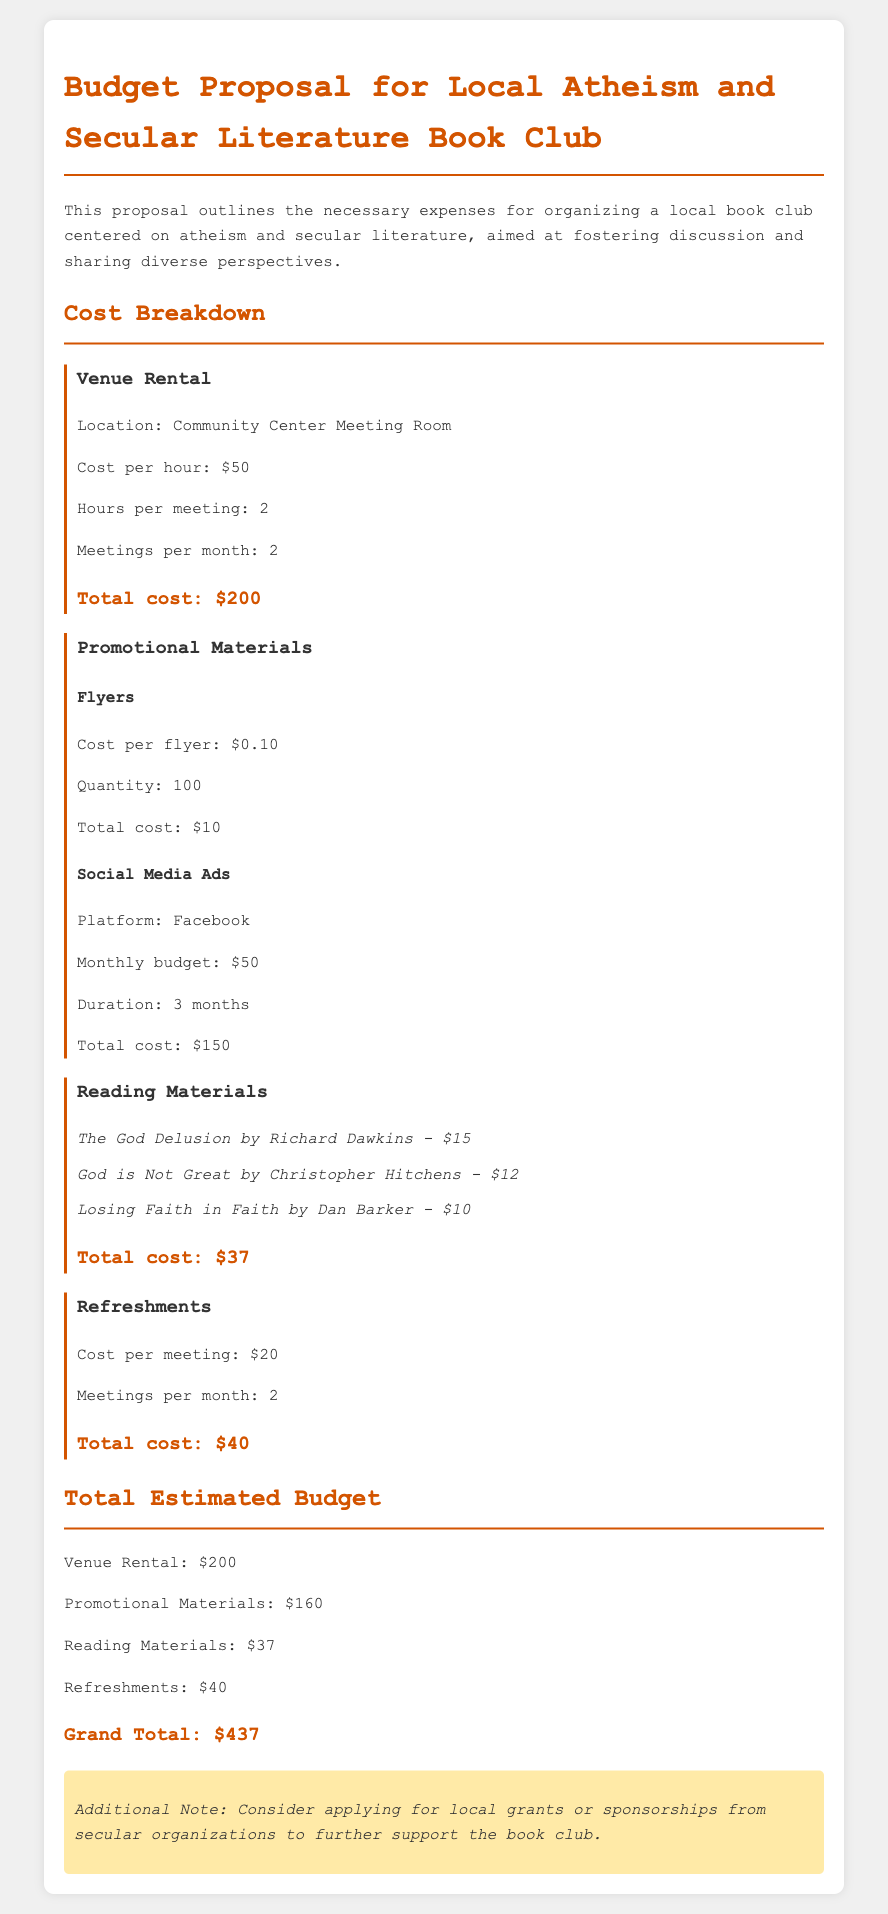What is the venue for the book club meetings? The document states that the venue for the meetings is the Community Center Meeting Room.
Answer: Community Center Meeting Room What is the cost per hour for the venue rental? The cost per hour for the venue rental is specified in the document as $50.
Answer: $50 How many meetings are planned per month? The document indicates that there will be 2 meetings per month.
Answer: 2 What is the total cost for reading materials? The total cost for reading materials is listed as $37 in the document.
Answer: $37 How much is allocated for promotional materials? The total cost for promotional materials, including flyers and social media ads, is $160.
Answer: $160 How many flyers are planned for distribution? The document states that 100 flyers are planned for distribution.
Answer: 100 What is the cost per meeting for refreshments? The document specifies that the cost per meeting for refreshments is $20.
Answer: $20 What is the grand total of the estimated budget? The grand total, as stated in the document, is $437.
Answer: $437 What is an additional suggestion provided in the document? The document suggests considering applying for local grants or sponsorships.
Answer: Grants or sponsorships 